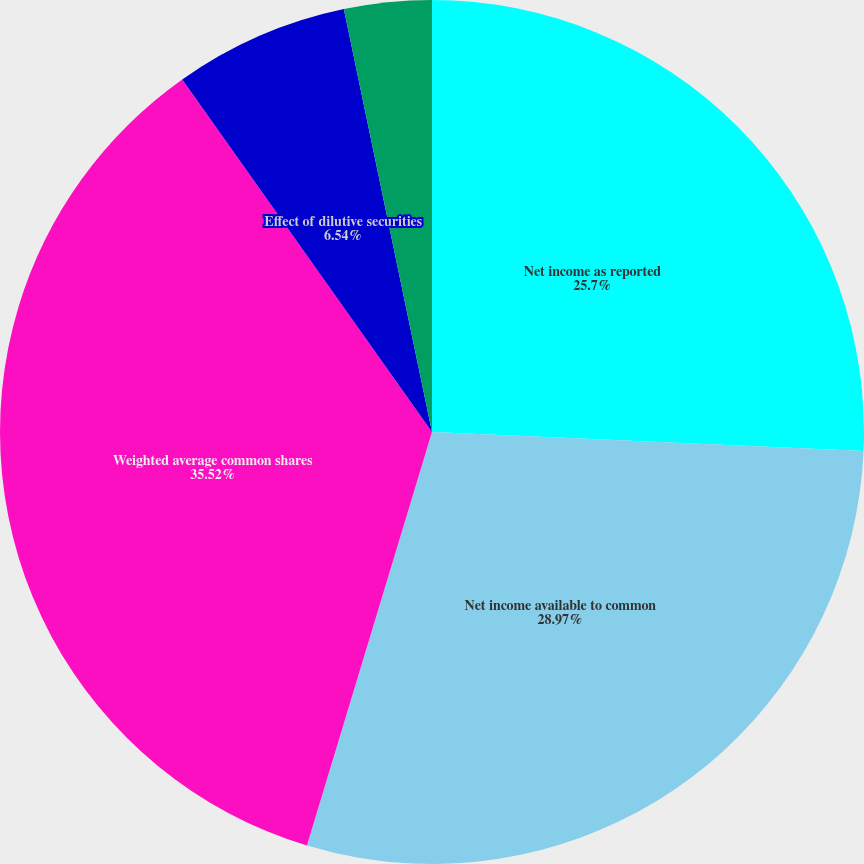Convert chart to OTSL. <chart><loc_0><loc_0><loc_500><loc_500><pie_chart><fcel>Net income as reported<fcel>Net income available to common<fcel>Weighted average common shares<fcel>Effect of dilutive securities<fcel>Earnings per share-basic<fcel>Earnings per share-diluted<nl><fcel>25.7%<fcel>28.97%<fcel>35.51%<fcel>6.54%<fcel>3.27%<fcel>0.0%<nl></chart> 